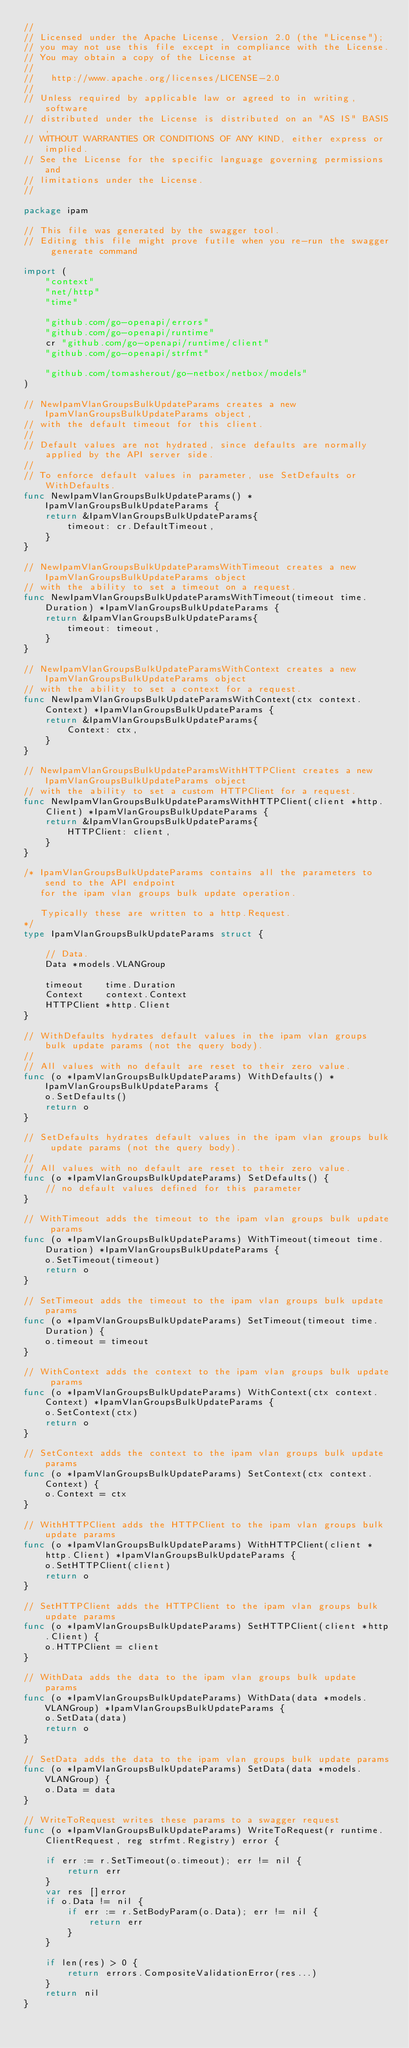<code> <loc_0><loc_0><loc_500><loc_500><_Go_>//
// Licensed under the Apache License, Version 2.0 (the "License");
// you may not use this file except in compliance with the License.
// You may obtain a copy of the License at
//
//   http://www.apache.org/licenses/LICENSE-2.0
//
// Unless required by applicable law or agreed to in writing, software
// distributed under the License is distributed on an "AS IS" BASIS,
// WITHOUT WARRANTIES OR CONDITIONS OF ANY KIND, either express or implied.
// See the License for the specific language governing permissions and
// limitations under the License.
//

package ipam

// This file was generated by the swagger tool.
// Editing this file might prove futile when you re-run the swagger generate command

import (
	"context"
	"net/http"
	"time"

	"github.com/go-openapi/errors"
	"github.com/go-openapi/runtime"
	cr "github.com/go-openapi/runtime/client"
	"github.com/go-openapi/strfmt"

	"github.com/tomasherout/go-netbox/netbox/models"
)

// NewIpamVlanGroupsBulkUpdateParams creates a new IpamVlanGroupsBulkUpdateParams object,
// with the default timeout for this client.
//
// Default values are not hydrated, since defaults are normally applied by the API server side.
//
// To enforce default values in parameter, use SetDefaults or WithDefaults.
func NewIpamVlanGroupsBulkUpdateParams() *IpamVlanGroupsBulkUpdateParams {
	return &IpamVlanGroupsBulkUpdateParams{
		timeout: cr.DefaultTimeout,
	}
}

// NewIpamVlanGroupsBulkUpdateParamsWithTimeout creates a new IpamVlanGroupsBulkUpdateParams object
// with the ability to set a timeout on a request.
func NewIpamVlanGroupsBulkUpdateParamsWithTimeout(timeout time.Duration) *IpamVlanGroupsBulkUpdateParams {
	return &IpamVlanGroupsBulkUpdateParams{
		timeout: timeout,
	}
}

// NewIpamVlanGroupsBulkUpdateParamsWithContext creates a new IpamVlanGroupsBulkUpdateParams object
// with the ability to set a context for a request.
func NewIpamVlanGroupsBulkUpdateParamsWithContext(ctx context.Context) *IpamVlanGroupsBulkUpdateParams {
	return &IpamVlanGroupsBulkUpdateParams{
		Context: ctx,
	}
}

// NewIpamVlanGroupsBulkUpdateParamsWithHTTPClient creates a new IpamVlanGroupsBulkUpdateParams object
// with the ability to set a custom HTTPClient for a request.
func NewIpamVlanGroupsBulkUpdateParamsWithHTTPClient(client *http.Client) *IpamVlanGroupsBulkUpdateParams {
	return &IpamVlanGroupsBulkUpdateParams{
		HTTPClient: client,
	}
}

/* IpamVlanGroupsBulkUpdateParams contains all the parameters to send to the API endpoint
   for the ipam vlan groups bulk update operation.

   Typically these are written to a http.Request.
*/
type IpamVlanGroupsBulkUpdateParams struct {

	// Data.
	Data *models.VLANGroup

	timeout    time.Duration
	Context    context.Context
	HTTPClient *http.Client
}

// WithDefaults hydrates default values in the ipam vlan groups bulk update params (not the query body).
//
// All values with no default are reset to their zero value.
func (o *IpamVlanGroupsBulkUpdateParams) WithDefaults() *IpamVlanGroupsBulkUpdateParams {
	o.SetDefaults()
	return o
}

// SetDefaults hydrates default values in the ipam vlan groups bulk update params (not the query body).
//
// All values with no default are reset to their zero value.
func (o *IpamVlanGroupsBulkUpdateParams) SetDefaults() {
	// no default values defined for this parameter
}

// WithTimeout adds the timeout to the ipam vlan groups bulk update params
func (o *IpamVlanGroupsBulkUpdateParams) WithTimeout(timeout time.Duration) *IpamVlanGroupsBulkUpdateParams {
	o.SetTimeout(timeout)
	return o
}

// SetTimeout adds the timeout to the ipam vlan groups bulk update params
func (o *IpamVlanGroupsBulkUpdateParams) SetTimeout(timeout time.Duration) {
	o.timeout = timeout
}

// WithContext adds the context to the ipam vlan groups bulk update params
func (o *IpamVlanGroupsBulkUpdateParams) WithContext(ctx context.Context) *IpamVlanGroupsBulkUpdateParams {
	o.SetContext(ctx)
	return o
}

// SetContext adds the context to the ipam vlan groups bulk update params
func (o *IpamVlanGroupsBulkUpdateParams) SetContext(ctx context.Context) {
	o.Context = ctx
}

// WithHTTPClient adds the HTTPClient to the ipam vlan groups bulk update params
func (o *IpamVlanGroupsBulkUpdateParams) WithHTTPClient(client *http.Client) *IpamVlanGroupsBulkUpdateParams {
	o.SetHTTPClient(client)
	return o
}

// SetHTTPClient adds the HTTPClient to the ipam vlan groups bulk update params
func (o *IpamVlanGroupsBulkUpdateParams) SetHTTPClient(client *http.Client) {
	o.HTTPClient = client
}

// WithData adds the data to the ipam vlan groups bulk update params
func (o *IpamVlanGroupsBulkUpdateParams) WithData(data *models.VLANGroup) *IpamVlanGroupsBulkUpdateParams {
	o.SetData(data)
	return o
}

// SetData adds the data to the ipam vlan groups bulk update params
func (o *IpamVlanGroupsBulkUpdateParams) SetData(data *models.VLANGroup) {
	o.Data = data
}

// WriteToRequest writes these params to a swagger request
func (o *IpamVlanGroupsBulkUpdateParams) WriteToRequest(r runtime.ClientRequest, reg strfmt.Registry) error {

	if err := r.SetTimeout(o.timeout); err != nil {
		return err
	}
	var res []error
	if o.Data != nil {
		if err := r.SetBodyParam(o.Data); err != nil {
			return err
		}
	}

	if len(res) > 0 {
		return errors.CompositeValidationError(res...)
	}
	return nil
}
</code> 